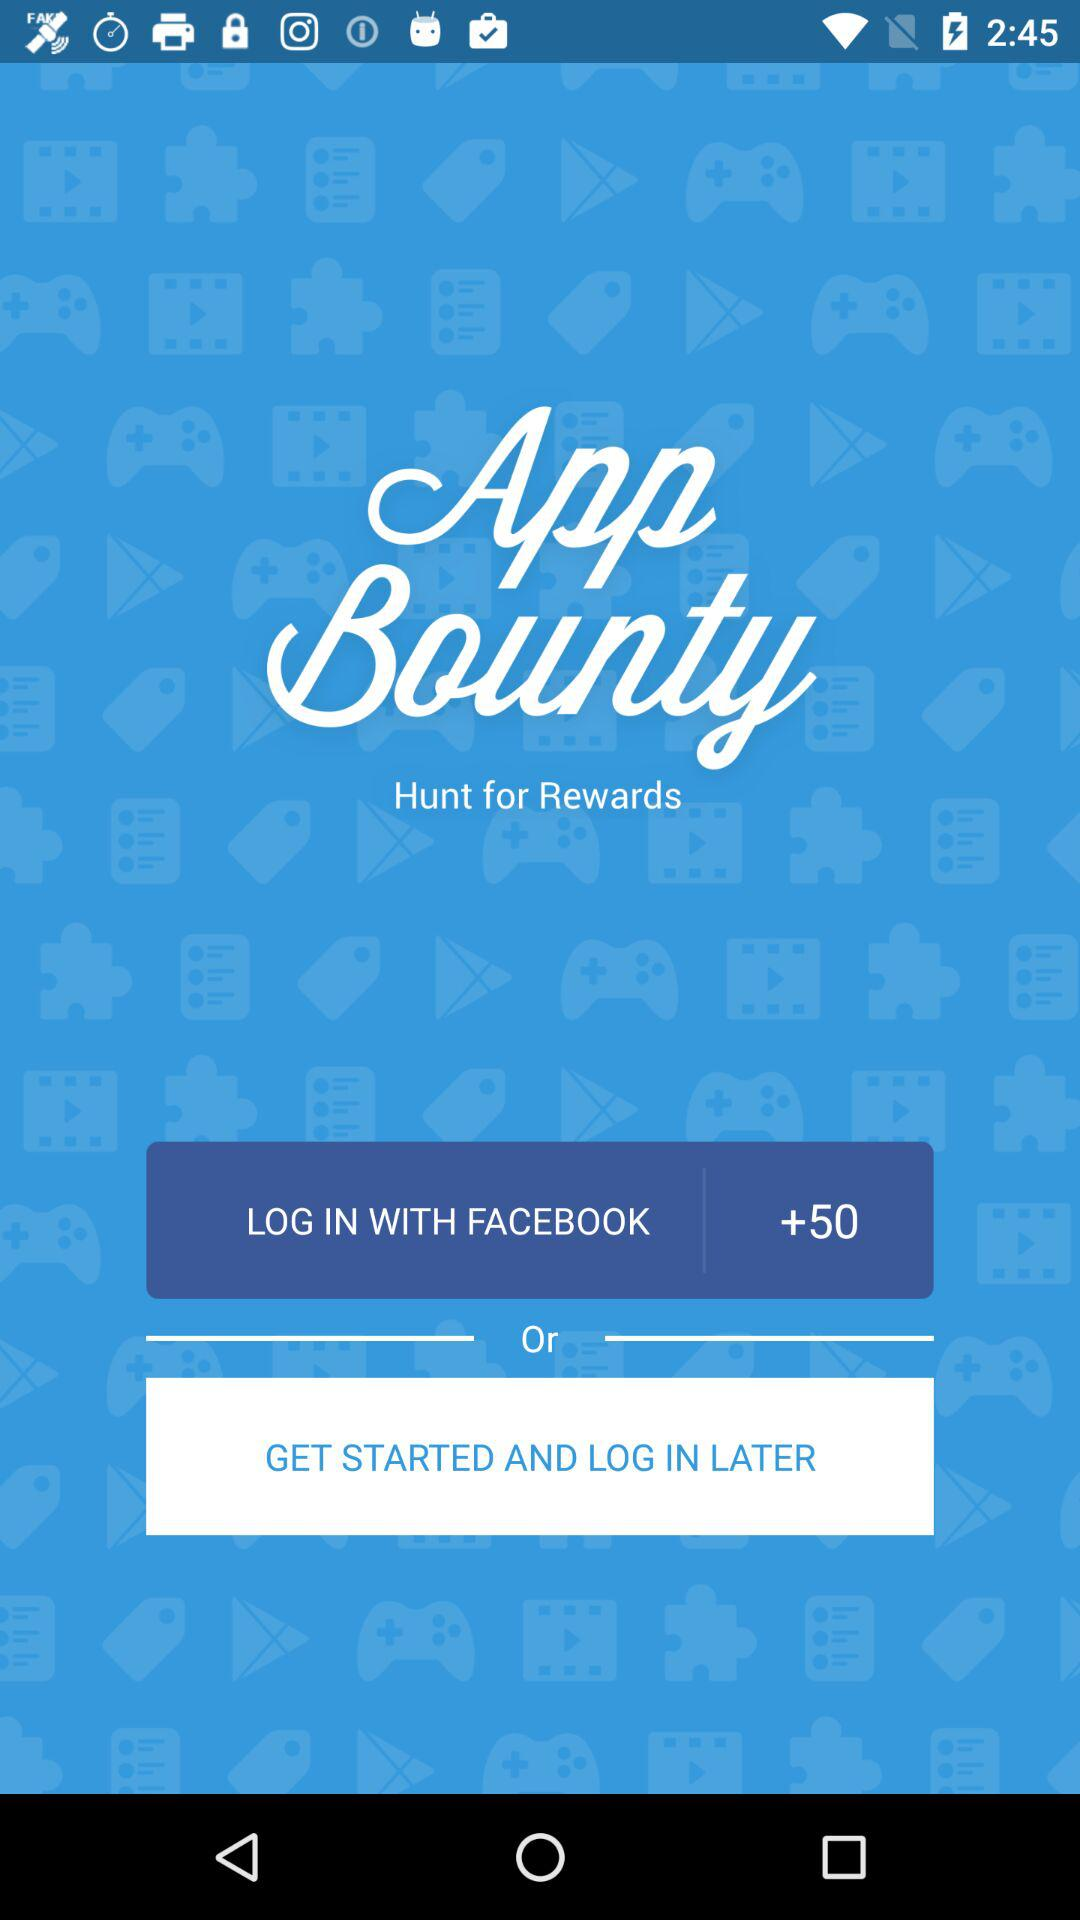How many more points can I earn if I log in with Facebook?
Answer the question using a single word or phrase. 50 